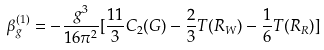Convert formula to latex. <formula><loc_0><loc_0><loc_500><loc_500>\beta _ { g } ^ { ( 1 ) } = - \frac { g ^ { 3 } } { 1 6 \pi ^ { 2 } } [ \frac { 1 1 } { 3 } C _ { 2 } ( G ) - \frac { 2 } { 3 } T ( R _ { W } ) - \frac { 1 } { 6 } T ( R _ { R } ) ]</formula> 